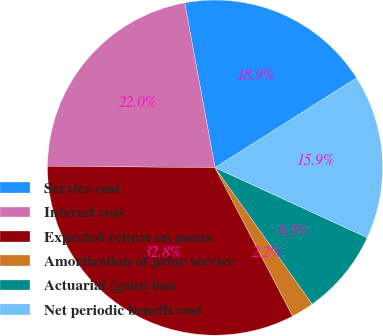Convert chart to OTSL. <chart><loc_0><loc_0><loc_500><loc_500><pie_chart><fcel>Service cost<fcel>Interest cost<fcel>Expected return on assets<fcel>Amortization of prior service<fcel>Actuarial (gain) loss<fcel>Net periodic benefit cost<nl><fcel>18.91%<fcel>21.97%<fcel>32.79%<fcel>2.18%<fcel>8.29%<fcel>15.85%<nl></chart> 